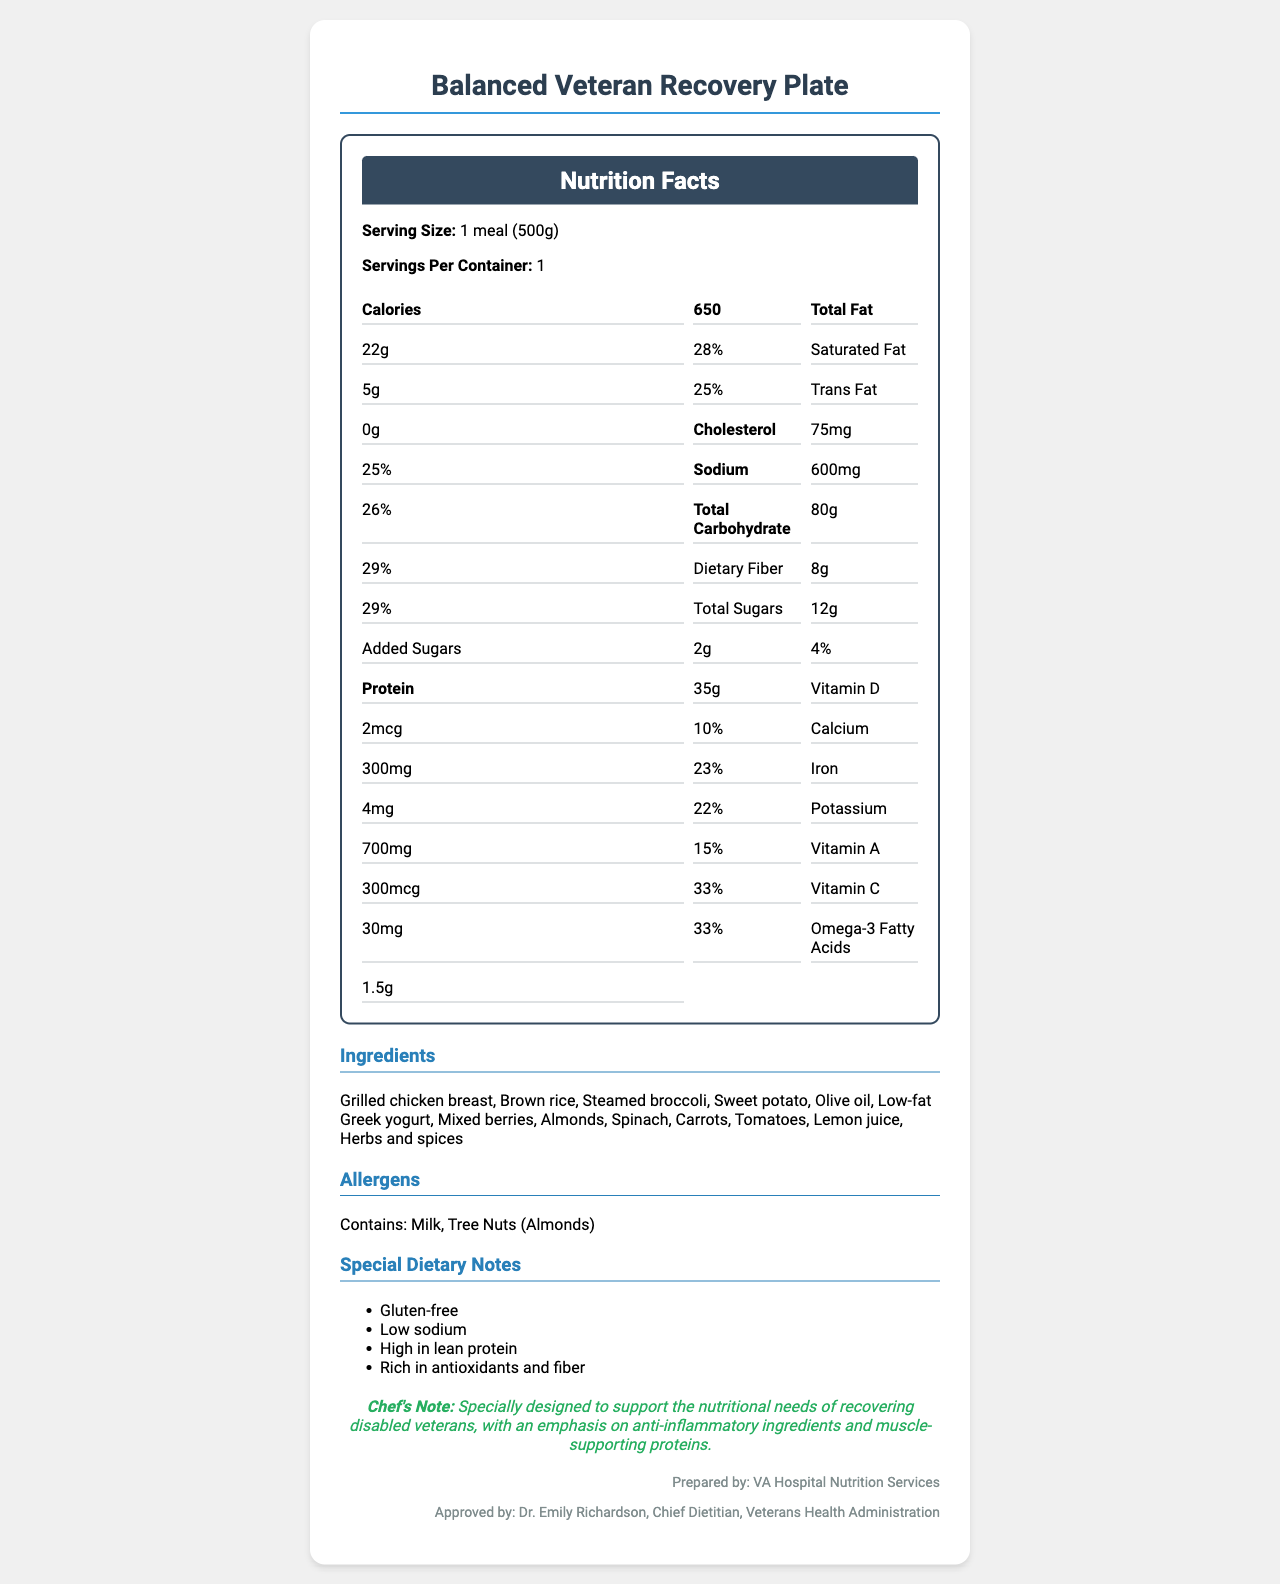how many servings are in one container? The document specifies "Servings Per Container: 1".
Answer: 1 what is the serving size for the meal? The serving size is clearly mentioned as "1 meal (500g)".
Answer: 1 meal (500g) how many calories are in one serving? The document lists the number of calories per serving as 650.
Answer: 650 what percentage of the daily value for sodium does one serving provide? The sodium daily value percentage is given as 26%.
Answer: 26% how much protein does the meal contain? The document states the amount of protein as 35g.
Answer: 35g which allergen is present in the meal? The allergens section lists Milk and Tree Nuts (Almonds) as present in the meal.
Answer: Contains: Milk, Tree Nuts (Almonds) what is the amount of vitamin C in the meal? The document lists the vitamin C content as 30mg.
Answer: 30mg why is this meal specially designed according to the chef's note? The chef's note specifies these reasons for the meal's design.
Answer: To support the nutritional needs of recovering disabled veterans, with an emphasis on anti-inflammatory ingredients and muscle-supporting proteins how much added sugars does this meal contain in one serving? The added sugars amount is mentioned as 2g.
Answer: 2g is this meal high in lean protein? The special dietary notes include that the meal is "High in lean protein".
Answer: Yes does this meal meet the gluten-free dietary requirement? The special dietary notes include "Gluten-free".
Answer: Yes which of the following is not listed as an ingredient in the meal? A. Grilled chicken breast B. Brown rice C. Low-fat Greek yogurt D. Beef Beef is not listed among the ingredients; the document lists Grilled chicken breast, Brown rice, Low-fat Greek yogurt but not Beef.
Answer: D what is the daily value percentage for calcium provided by the meal? A. 23% B. 25% C. 26% D. 28% The document mentions that the daily value percentage for calcium is 23%.
Answer: A which nutrient has the highest daily value percentage in this meal? A. Calcium B. Vitamin C C. Total Fat D. Vitamin A Vitamin C and Vitamin A both have a daily value of 33%, which is the highest among listed nutrients.
Answer: B how would you summarize the main idea of this document? The document provides comprehensive details on nutrition, ingredients, allergens, and diet specifics, designed to aid in veterans' recovery through balanced nutrition.
Answer: The document details the nutritional information, ingredients, allergens, and special dietary notes of the Balanced Veteran Recovery Plate meal, emphasizing its benefits for disabled veterans. what is the preparation method of the chicken mentioned in the meal? The document does not specify the preparation method of the chicken beyond mentioning it is a grilled chicken breast.
Answer: Cannot be determined who approved this meal plan? The approval is attributed to Dr. Emily Richardson as noted in the document.
Answer: Dr. Emily Richardson, Chief Dietitian, Veterans Health Administration 